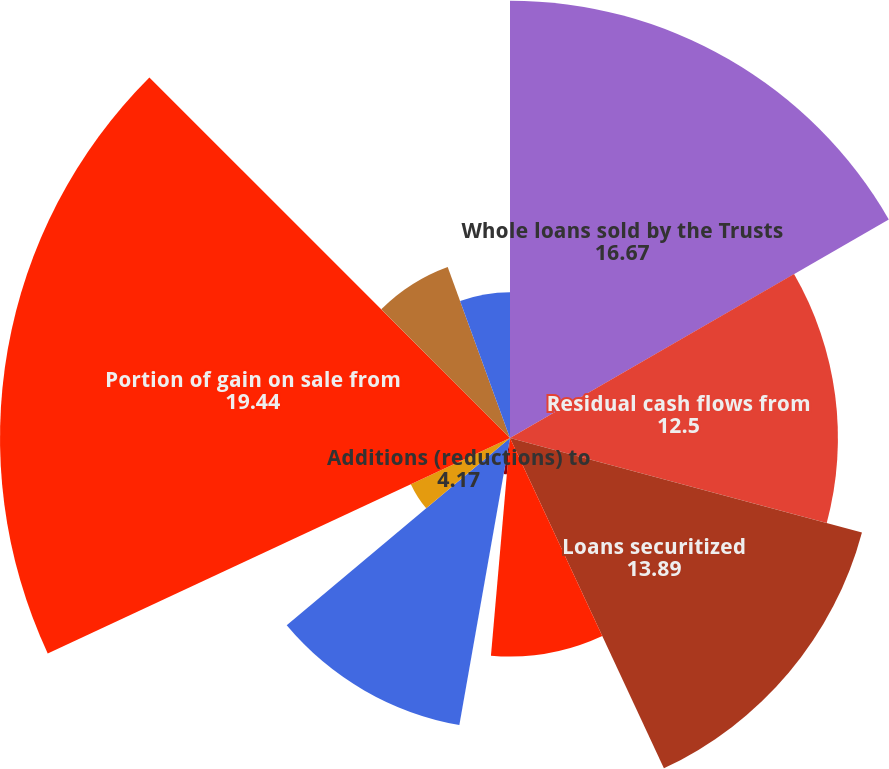Convert chart to OTSL. <chart><loc_0><loc_0><loc_500><loc_500><pie_chart><fcel>Whole loans sold by the Trusts<fcel>Residual cash flows from<fcel>Loans securitized<fcel>Sale of previously securitized<fcel>Gain (loss) on derivative<fcel>Retained mortgage servicing<fcel>Additions (reductions) to<fcel>Portion of gain on sale from<fcel>Changes in beneficial interest<fcel>Impairments to fair value of<nl><fcel>16.67%<fcel>12.5%<fcel>13.89%<fcel>8.33%<fcel>1.39%<fcel>11.11%<fcel>4.17%<fcel>19.44%<fcel>6.94%<fcel>5.56%<nl></chart> 